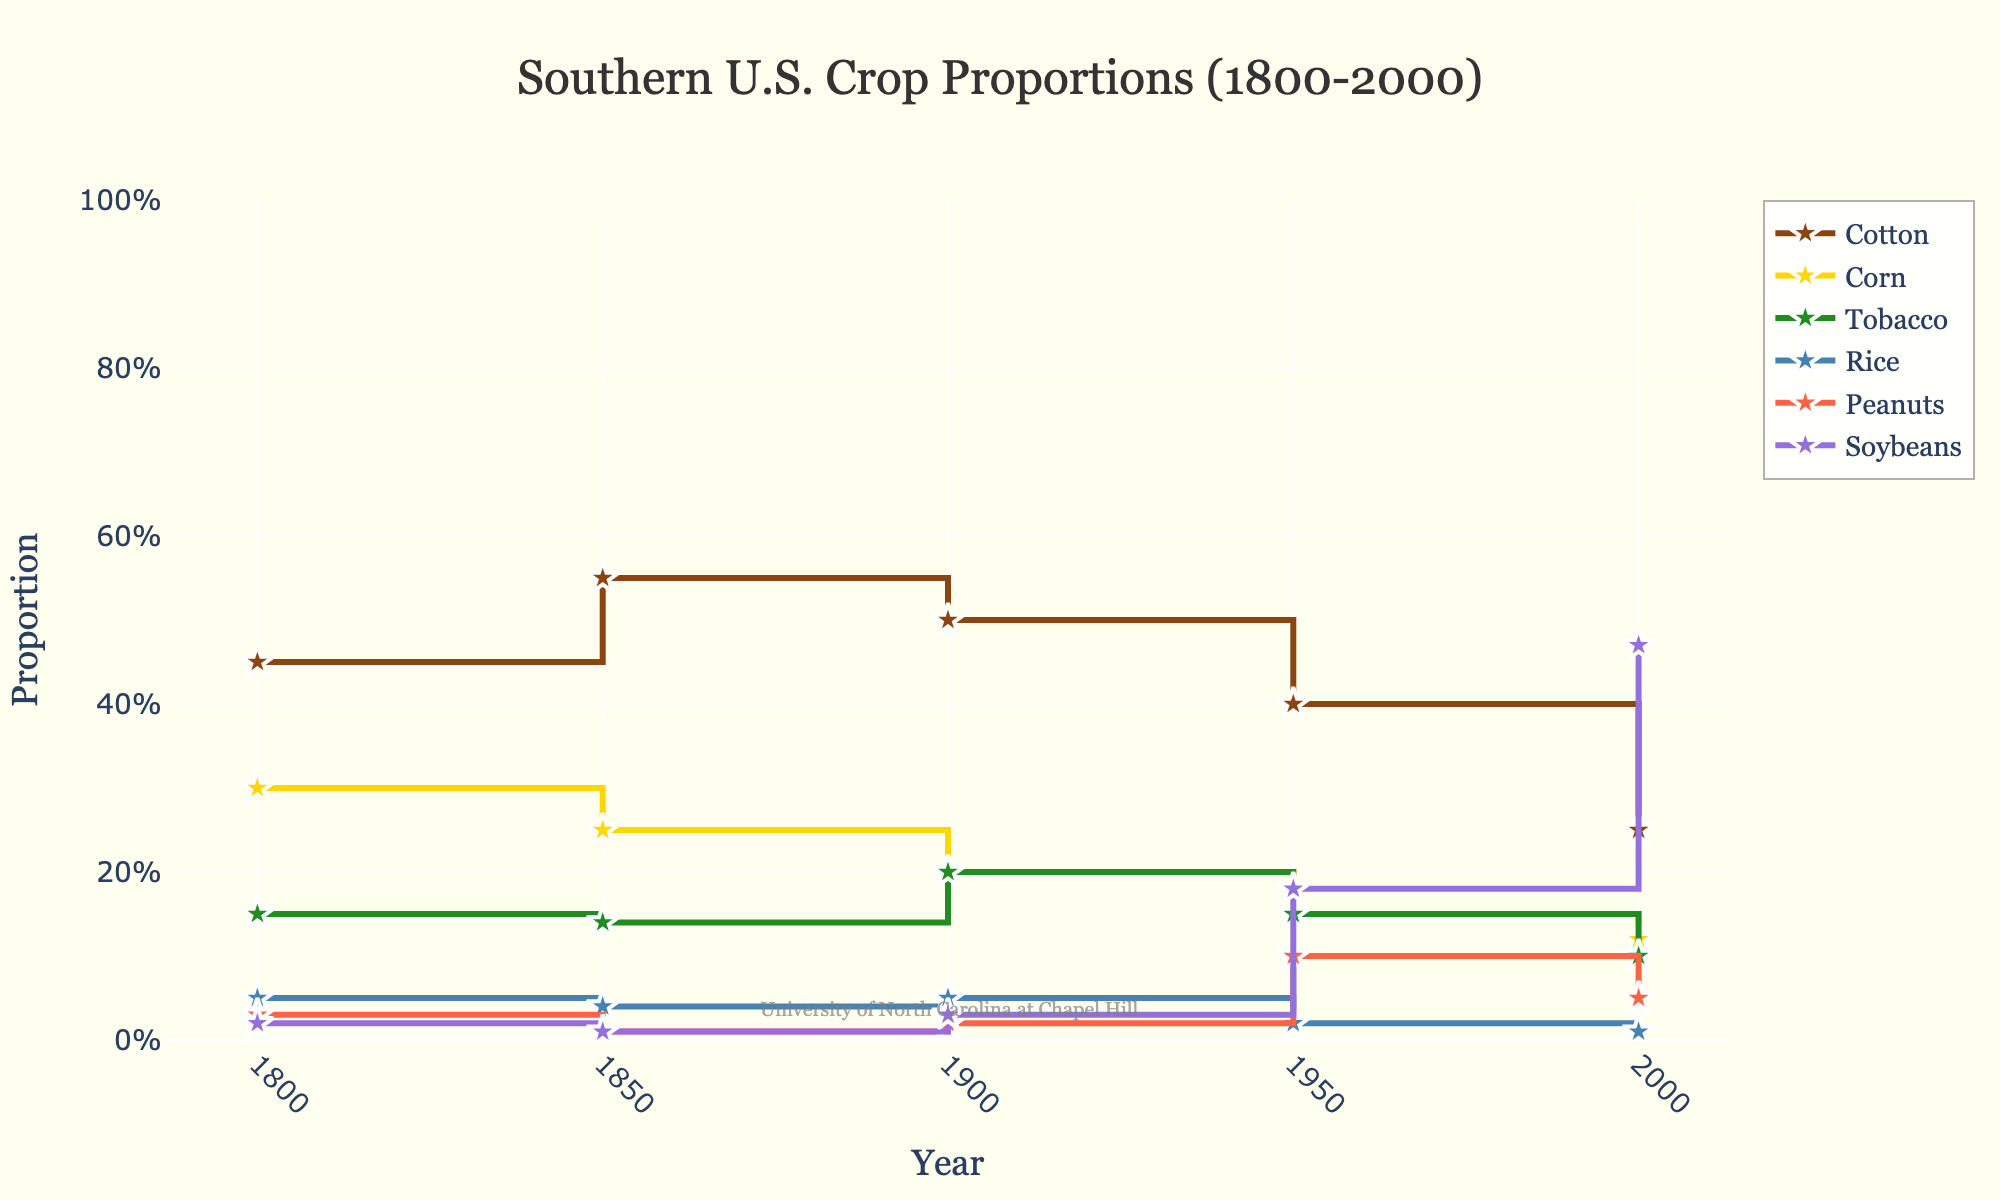what is the title of the plot? The title is located at the top center of the plot and provides an overview of what the plot is about. The title reads "Southern U.S. Crop Proportions (1800-2000)"
Answer: Southern U.S. Crop Proportions (1800-2000) what is the y-axis title? The y-axis title, which is located along the left vertical axis of the plot, indicates that the y-axis represents the proportion of each crop. It reads "Proportion"
Answer: Proportion which crop had the highest proportion in the year 1800? The plot shows the proportions of various crops for each year. For 1800, the crop with the highest proportion is Cotton, indicated by the highest point on the stair for the year 1800.
Answer: Cotton how did the proportion of tobacco change from 1800 to 2000? By looking at the plot, we can see that the proportion of Tobacco first remained steady between 1800 (0.15) and 1850 (0.14), increased slightly by 1900 (0.20), and then decreased by 1950 (0.15) and further by 2000 (0.10)
Answer: it decreased from 0.15 to 0.10 what is the average proportion of soybeans from 1900 to 2000? To find the average proportion of Soybeans, we look at the values for the years 1900 (0.03), 1950 (0.18), and 2000 (0.47). Add them up (0.03 + 0.18 + 0.47 = 0.68) and then divide by the number of years (3): 0.68 / 3 = 0.227.
Answer: 0.227 which crop did not show any visible change in proportion from 1800 to 2000? Looking at the plot, the Rice crop shows the least visible change, as its line remains nearly horizontal and close to 0.05 across all years.
Answer: Rice by how much did the proportion of corn decrease from 1800 to 2000? In 1800, the proportion of Corn was 0.30, and by 2000, it was 0.12. The decrease is calculated as 0.30 - 0.12 = 0.18
Answer: 0.18 which crop showed the greatest increase in proportion between 1950 and 2000? Evaluating the proportions in 1950 and 2000, Soybeans increased the most, from 0.18 in 1950 to 0.47 in 2000. The increase is calculated as 0.47 - 0.18 = 0.29
Answer: Soybeans in which year was the proportion of peanuts highest? From the plot, it's visible that the highest point for Peanuts occurs in the year 1950 when its proportion is 0.10
Answer: 1950 